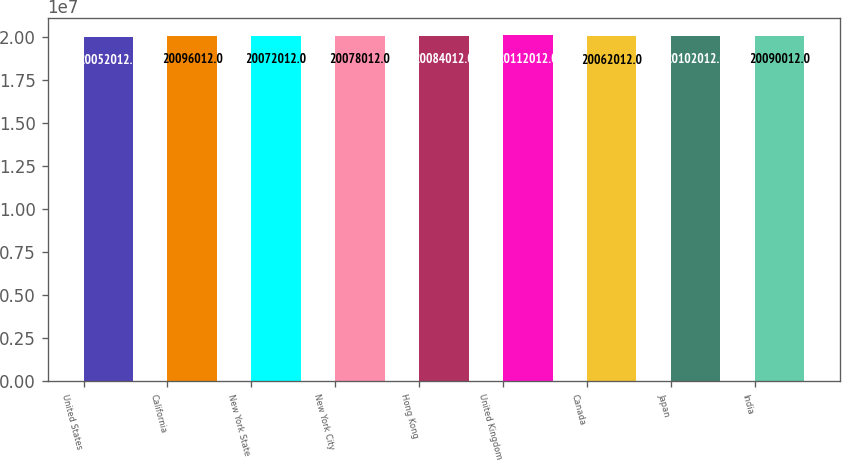Convert chart to OTSL. <chart><loc_0><loc_0><loc_500><loc_500><bar_chart><fcel>United States<fcel>California<fcel>New York State<fcel>New York City<fcel>Hong Kong<fcel>United Kingdom<fcel>Canada<fcel>Japan<fcel>India<nl><fcel>2.0052e+07<fcel>2.0096e+07<fcel>2.0072e+07<fcel>2.0078e+07<fcel>2.0084e+07<fcel>2.0112e+07<fcel>2.0062e+07<fcel>2.0102e+07<fcel>2.009e+07<nl></chart> 